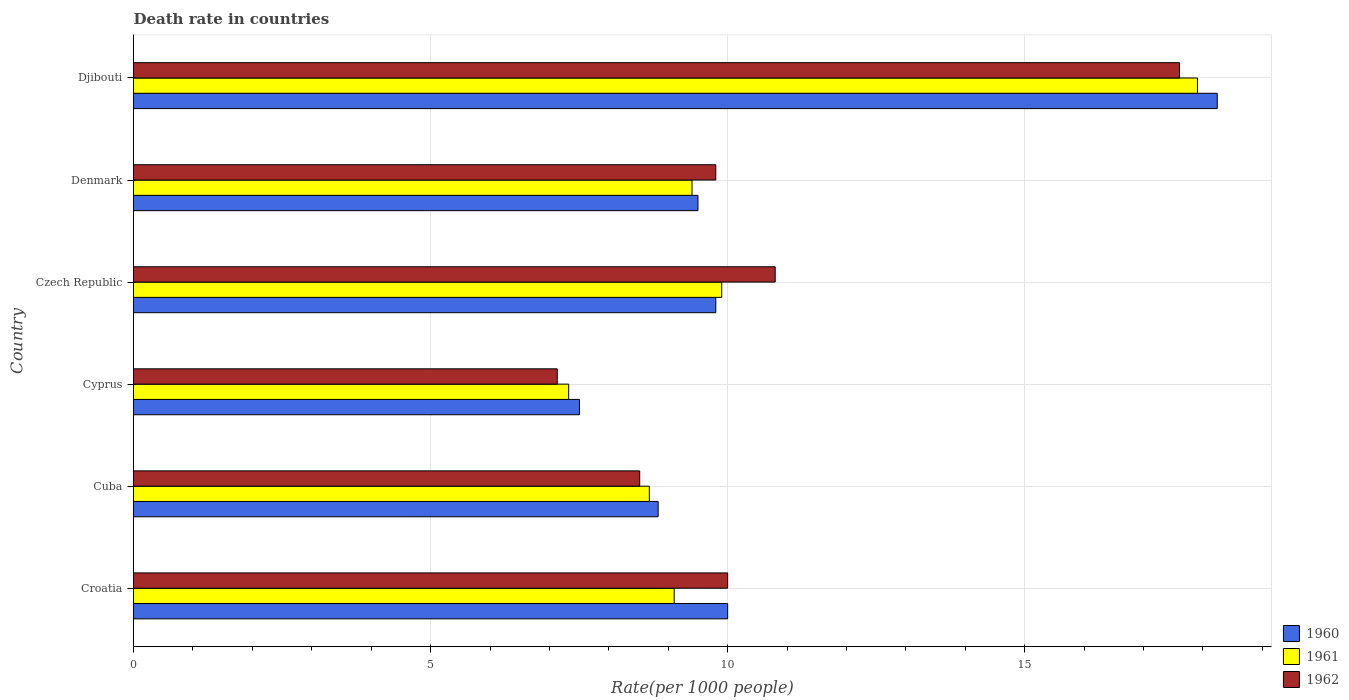How many groups of bars are there?
Your answer should be compact. 6. Are the number of bars per tick equal to the number of legend labels?
Offer a very short reply. Yes. How many bars are there on the 3rd tick from the top?
Provide a short and direct response. 3. What is the label of the 5th group of bars from the top?
Provide a short and direct response. Cuba. In how many cases, is the number of bars for a given country not equal to the number of legend labels?
Your answer should be very brief. 0. What is the death rate in 1962 in Croatia?
Ensure brevity in your answer.  10. Across all countries, what is the maximum death rate in 1962?
Make the answer very short. 17.6. Across all countries, what is the minimum death rate in 1960?
Your answer should be compact. 7.51. In which country was the death rate in 1962 maximum?
Keep it short and to the point. Djibouti. In which country was the death rate in 1962 minimum?
Offer a terse response. Cyprus. What is the total death rate in 1961 in the graph?
Your answer should be compact. 62.31. What is the difference between the death rate in 1960 in Cuba and that in Czech Republic?
Ensure brevity in your answer.  -0.97. What is the difference between the death rate in 1961 in Cuba and the death rate in 1962 in Djibouti?
Your answer should be compact. -8.92. What is the average death rate in 1962 per country?
Offer a terse response. 10.64. What is the difference between the death rate in 1960 and death rate in 1961 in Cuba?
Provide a succinct answer. 0.15. What is the ratio of the death rate in 1961 in Cuba to that in Djibouti?
Make the answer very short. 0.48. What is the difference between the highest and the second highest death rate in 1962?
Provide a short and direct response. 6.8. What is the difference between the highest and the lowest death rate in 1962?
Make the answer very short. 10.47. In how many countries, is the death rate in 1962 greater than the average death rate in 1962 taken over all countries?
Your answer should be very brief. 2. Is the sum of the death rate in 1960 in Croatia and Denmark greater than the maximum death rate in 1961 across all countries?
Offer a terse response. Yes. What does the 2nd bar from the bottom in Czech Republic represents?
Your response must be concise. 1961. How many bars are there?
Your response must be concise. 18. Are all the bars in the graph horizontal?
Provide a short and direct response. Yes. How many countries are there in the graph?
Offer a very short reply. 6. Are the values on the major ticks of X-axis written in scientific E-notation?
Offer a very short reply. No. Does the graph contain grids?
Make the answer very short. Yes. What is the title of the graph?
Your answer should be compact. Death rate in countries. Does "1966" appear as one of the legend labels in the graph?
Your answer should be very brief. No. What is the label or title of the X-axis?
Offer a terse response. Rate(per 1000 people). What is the label or title of the Y-axis?
Give a very brief answer. Country. What is the Rate(per 1000 people) of 1961 in Croatia?
Keep it short and to the point. 9.1. What is the Rate(per 1000 people) in 1960 in Cuba?
Offer a very short reply. 8.83. What is the Rate(per 1000 people) of 1961 in Cuba?
Provide a short and direct response. 8.68. What is the Rate(per 1000 people) of 1962 in Cuba?
Give a very brief answer. 8.52. What is the Rate(per 1000 people) in 1960 in Cyprus?
Your response must be concise. 7.51. What is the Rate(per 1000 people) in 1961 in Cyprus?
Offer a very short reply. 7.32. What is the Rate(per 1000 people) in 1962 in Cyprus?
Make the answer very short. 7.13. What is the Rate(per 1000 people) in 1960 in Czech Republic?
Make the answer very short. 9.8. What is the Rate(per 1000 people) of 1962 in Czech Republic?
Your answer should be very brief. 10.8. What is the Rate(per 1000 people) of 1962 in Denmark?
Give a very brief answer. 9.8. What is the Rate(per 1000 people) of 1960 in Djibouti?
Provide a short and direct response. 18.24. What is the Rate(per 1000 people) of 1961 in Djibouti?
Your answer should be compact. 17.91. What is the Rate(per 1000 people) of 1962 in Djibouti?
Ensure brevity in your answer.  17.6. Across all countries, what is the maximum Rate(per 1000 people) in 1960?
Provide a short and direct response. 18.24. Across all countries, what is the maximum Rate(per 1000 people) in 1961?
Your answer should be compact. 17.91. Across all countries, what is the maximum Rate(per 1000 people) of 1962?
Your answer should be compact. 17.6. Across all countries, what is the minimum Rate(per 1000 people) in 1960?
Provide a short and direct response. 7.51. Across all countries, what is the minimum Rate(per 1000 people) in 1961?
Keep it short and to the point. 7.32. Across all countries, what is the minimum Rate(per 1000 people) of 1962?
Keep it short and to the point. 7.13. What is the total Rate(per 1000 people) in 1960 in the graph?
Your response must be concise. 63.88. What is the total Rate(per 1000 people) in 1961 in the graph?
Your answer should be compact. 62.31. What is the total Rate(per 1000 people) of 1962 in the graph?
Keep it short and to the point. 63.86. What is the difference between the Rate(per 1000 people) in 1960 in Croatia and that in Cuba?
Give a very brief answer. 1.17. What is the difference between the Rate(per 1000 people) of 1961 in Croatia and that in Cuba?
Provide a succinct answer. 0.42. What is the difference between the Rate(per 1000 people) of 1962 in Croatia and that in Cuba?
Provide a succinct answer. 1.48. What is the difference between the Rate(per 1000 people) in 1960 in Croatia and that in Cyprus?
Your answer should be very brief. 2.49. What is the difference between the Rate(per 1000 people) in 1961 in Croatia and that in Cyprus?
Offer a very short reply. 1.78. What is the difference between the Rate(per 1000 people) of 1962 in Croatia and that in Cyprus?
Your response must be concise. 2.87. What is the difference between the Rate(per 1000 people) of 1962 in Croatia and that in Czech Republic?
Offer a terse response. -0.8. What is the difference between the Rate(per 1000 people) in 1960 in Croatia and that in Denmark?
Make the answer very short. 0.5. What is the difference between the Rate(per 1000 people) in 1961 in Croatia and that in Denmark?
Provide a succinct answer. -0.3. What is the difference between the Rate(per 1000 people) in 1962 in Croatia and that in Denmark?
Your response must be concise. 0.2. What is the difference between the Rate(per 1000 people) of 1960 in Croatia and that in Djibouti?
Offer a terse response. -8.24. What is the difference between the Rate(per 1000 people) of 1961 in Croatia and that in Djibouti?
Ensure brevity in your answer.  -8.81. What is the difference between the Rate(per 1000 people) of 1962 in Croatia and that in Djibouti?
Offer a very short reply. -7.6. What is the difference between the Rate(per 1000 people) of 1960 in Cuba and that in Cyprus?
Ensure brevity in your answer.  1.32. What is the difference between the Rate(per 1000 people) in 1961 in Cuba and that in Cyprus?
Keep it short and to the point. 1.36. What is the difference between the Rate(per 1000 people) in 1962 in Cuba and that in Cyprus?
Keep it short and to the point. 1.39. What is the difference between the Rate(per 1000 people) of 1960 in Cuba and that in Czech Republic?
Ensure brevity in your answer.  -0.97. What is the difference between the Rate(per 1000 people) in 1961 in Cuba and that in Czech Republic?
Give a very brief answer. -1.22. What is the difference between the Rate(per 1000 people) in 1962 in Cuba and that in Czech Republic?
Keep it short and to the point. -2.28. What is the difference between the Rate(per 1000 people) of 1960 in Cuba and that in Denmark?
Make the answer very short. -0.67. What is the difference between the Rate(per 1000 people) in 1961 in Cuba and that in Denmark?
Keep it short and to the point. -0.72. What is the difference between the Rate(per 1000 people) of 1962 in Cuba and that in Denmark?
Provide a succinct answer. -1.28. What is the difference between the Rate(per 1000 people) in 1960 in Cuba and that in Djibouti?
Offer a very short reply. -9.41. What is the difference between the Rate(per 1000 people) in 1961 in Cuba and that in Djibouti?
Your response must be concise. -9.22. What is the difference between the Rate(per 1000 people) in 1962 in Cuba and that in Djibouti?
Make the answer very short. -9.08. What is the difference between the Rate(per 1000 people) of 1960 in Cyprus and that in Czech Republic?
Your response must be concise. -2.29. What is the difference between the Rate(per 1000 people) in 1961 in Cyprus and that in Czech Republic?
Offer a terse response. -2.58. What is the difference between the Rate(per 1000 people) in 1962 in Cyprus and that in Czech Republic?
Provide a short and direct response. -3.67. What is the difference between the Rate(per 1000 people) in 1960 in Cyprus and that in Denmark?
Provide a short and direct response. -1.99. What is the difference between the Rate(per 1000 people) in 1961 in Cyprus and that in Denmark?
Offer a very short reply. -2.08. What is the difference between the Rate(per 1000 people) in 1962 in Cyprus and that in Denmark?
Offer a terse response. -2.67. What is the difference between the Rate(per 1000 people) in 1960 in Cyprus and that in Djibouti?
Your response must be concise. -10.73. What is the difference between the Rate(per 1000 people) in 1961 in Cyprus and that in Djibouti?
Offer a terse response. -10.58. What is the difference between the Rate(per 1000 people) of 1962 in Cyprus and that in Djibouti?
Provide a short and direct response. -10.47. What is the difference between the Rate(per 1000 people) in 1961 in Czech Republic and that in Denmark?
Your answer should be compact. 0.5. What is the difference between the Rate(per 1000 people) in 1962 in Czech Republic and that in Denmark?
Offer a very short reply. 1. What is the difference between the Rate(per 1000 people) of 1960 in Czech Republic and that in Djibouti?
Offer a very short reply. -8.44. What is the difference between the Rate(per 1000 people) in 1961 in Czech Republic and that in Djibouti?
Offer a very short reply. -8.01. What is the difference between the Rate(per 1000 people) of 1962 in Czech Republic and that in Djibouti?
Provide a succinct answer. -6.8. What is the difference between the Rate(per 1000 people) in 1960 in Denmark and that in Djibouti?
Your answer should be very brief. -8.74. What is the difference between the Rate(per 1000 people) in 1961 in Denmark and that in Djibouti?
Offer a terse response. -8.51. What is the difference between the Rate(per 1000 people) of 1962 in Denmark and that in Djibouti?
Your answer should be compact. -7.8. What is the difference between the Rate(per 1000 people) of 1960 in Croatia and the Rate(per 1000 people) of 1961 in Cuba?
Give a very brief answer. 1.32. What is the difference between the Rate(per 1000 people) in 1960 in Croatia and the Rate(per 1000 people) in 1962 in Cuba?
Give a very brief answer. 1.48. What is the difference between the Rate(per 1000 people) in 1961 in Croatia and the Rate(per 1000 people) in 1962 in Cuba?
Offer a very short reply. 0.58. What is the difference between the Rate(per 1000 people) in 1960 in Croatia and the Rate(per 1000 people) in 1961 in Cyprus?
Provide a succinct answer. 2.68. What is the difference between the Rate(per 1000 people) in 1960 in Croatia and the Rate(per 1000 people) in 1962 in Cyprus?
Offer a terse response. 2.87. What is the difference between the Rate(per 1000 people) in 1961 in Croatia and the Rate(per 1000 people) in 1962 in Cyprus?
Ensure brevity in your answer.  1.97. What is the difference between the Rate(per 1000 people) in 1960 in Croatia and the Rate(per 1000 people) in 1961 in Czech Republic?
Offer a very short reply. 0.1. What is the difference between the Rate(per 1000 people) in 1960 in Croatia and the Rate(per 1000 people) in 1962 in Denmark?
Make the answer very short. 0.2. What is the difference between the Rate(per 1000 people) in 1961 in Croatia and the Rate(per 1000 people) in 1962 in Denmark?
Provide a succinct answer. -0.7. What is the difference between the Rate(per 1000 people) of 1960 in Croatia and the Rate(per 1000 people) of 1961 in Djibouti?
Give a very brief answer. -7.91. What is the difference between the Rate(per 1000 people) in 1960 in Croatia and the Rate(per 1000 people) in 1962 in Djibouti?
Your response must be concise. -7.6. What is the difference between the Rate(per 1000 people) in 1961 in Croatia and the Rate(per 1000 people) in 1962 in Djibouti?
Offer a terse response. -8.5. What is the difference between the Rate(per 1000 people) of 1960 in Cuba and the Rate(per 1000 people) of 1961 in Cyprus?
Provide a succinct answer. 1.51. What is the difference between the Rate(per 1000 people) of 1960 in Cuba and the Rate(per 1000 people) of 1962 in Cyprus?
Give a very brief answer. 1.7. What is the difference between the Rate(per 1000 people) in 1961 in Cuba and the Rate(per 1000 people) in 1962 in Cyprus?
Give a very brief answer. 1.55. What is the difference between the Rate(per 1000 people) in 1960 in Cuba and the Rate(per 1000 people) in 1961 in Czech Republic?
Your response must be concise. -1.07. What is the difference between the Rate(per 1000 people) in 1960 in Cuba and the Rate(per 1000 people) in 1962 in Czech Republic?
Keep it short and to the point. -1.97. What is the difference between the Rate(per 1000 people) in 1961 in Cuba and the Rate(per 1000 people) in 1962 in Czech Republic?
Provide a short and direct response. -2.12. What is the difference between the Rate(per 1000 people) in 1960 in Cuba and the Rate(per 1000 people) in 1961 in Denmark?
Give a very brief answer. -0.57. What is the difference between the Rate(per 1000 people) of 1960 in Cuba and the Rate(per 1000 people) of 1962 in Denmark?
Give a very brief answer. -0.97. What is the difference between the Rate(per 1000 people) of 1961 in Cuba and the Rate(per 1000 people) of 1962 in Denmark?
Give a very brief answer. -1.12. What is the difference between the Rate(per 1000 people) of 1960 in Cuba and the Rate(per 1000 people) of 1961 in Djibouti?
Ensure brevity in your answer.  -9.08. What is the difference between the Rate(per 1000 people) in 1960 in Cuba and the Rate(per 1000 people) in 1962 in Djibouti?
Your response must be concise. -8.77. What is the difference between the Rate(per 1000 people) in 1961 in Cuba and the Rate(per 1000 people) in 1962 in Djibouti?
Keep it short and to the point. -8.92. What is the difference between the Rate(per 1000 people) in 1960 in Cyprus and the Rate(per 1000 people) in 1961 in Czech Republic?
Ensure brevity in your answer.  -2.39. What is the difference between the Rate(per 1000 people) in 1960 in Cyprus and the Rate(per 1000 people) in 1962 in Czech Republic?
Offer a very short reply. -3.29. What is the difference between the Rate(per 1000 people) in 1961 in Cyprus and the Rate(per 1000 people) in 1962 in Czech Republic?
Give a very brief answer. -3.48. What is the difference between the Rate(per 1000 people) in 1960 in Cyprus and the Rate(per 1000 people) in 1961 in Denmark?
Provide a succinct answer. -1.89. What is the difference between the Rate(per 1000 people) in 1960 in Cyprus and the Rate(per 1000 people) in 1962 in Denmark?
Your answer should be very brief. -2.29. What is the difference between the Rate(per 1000 people) in 1961 in Cyprus and the Rate(per 1000 people) in 1962 in Denmark?
Offer a terse response. -2.48. What is the difference between the Rate(per 1000 people) of 1960 in Cyprus and the Rate(per 1000 people) of 1961 in Djibouti?
Your answer should be compact. -10.4. What is the difference between the Rate(per 1000 people) of 1960 in Cyprus and the Rate(per 1000 people) of 1962 in Djibouti?
Ensure brevity in your answer.  -10.1. What is the difference between the Rate(per 1000 people) of 1961 in Cyprus and the Rate(per 1000 people) of 1962 in Djibouti?
Keep it short and to the point. -10.28. What is the difference between the Rate(per 1000 people) of 1960 in Czech Republic and the Rate(per 1000 people) of 1961 in Djibouti?
Offer a terse response. -8.11. What is the difference between the Rate(per 1000 people) in 1960 in Czech Republic and the Rate(per 1000 people) in 1962 in Djibouti?
Offer a very short reply. -7.8. What is the difference between the Rate(per 1000 people) in 1961 in Czech Republic and the Rate(per 1000 people) in 1962 in Djibouti?
Make the answer very short. -7.7. What is the difference between the Rate(per 1000 people) in 1960 in Denmark and the Rate(per 1000 people) in 1961 in Djibouti?
Your response must be concise. -8.41. What is the difference between the Rate(per 1000 people) of 1960 in Denmark and the Rate(per 1000 people) of 1962 in Djibouti?
Provide a succinct answer. -8.1. What is the difference between the Rate(per 1000 people) of 1961 in Denmark and the Rate(per 1000 people) of 1962 in Djibouti?
Make the answer very short. -8.2. What is the average Rate(per 1000 people) in 1960 per country?
Your response must be concise. 10.65. What is the average Rate(per 1000 people) in 1961 per country?
Your response must be concise. 10.39. What is the average Rate(per 1000 people) of 1962 per country?
Keep it short and to the point. 10.64. What is the difference between the Rate(per 1000 people) of 1960 and Rate(per 1000 people) of 1961 in Cuba?
Offer a very short reply. 0.15. What is the difference between the Rate(per 1000 people) in 1960 and Rate(per 1000 people) in 1962 in Cuba?
Give a very brief answer. 0.31. What is the difference between the Rate(per 1000 people) in 1961 and Rate(per 1000 people) in 1962 in Cuba?
Give a very brief answer. 0.16. What is the difference between the Rate(per 1000 people) of 1960 and Rate(per 1000 people) of 1961 in Cyprus?
Keep it short and to the point. 0.18. What is the difference between the Rate(per 1000 people) in 1960 and Rate(per 1000 people) in 1962 in Cyprus?
Provide a short and direct response. 0.37. What is the difference between the Rate(per 1000 people) of 1961 and Rate(per 1000 people) of 1962 in Cyprus?
Make the answer very short. 0.19. What is the difference between the Rate(per 1000 people) of 1960 and Rate(per 1000 people) of 1961 in Czech Republic?
Your answer should be very brief. -0.1. What is the difference between the Rate(per 1000 people) in 1961 and Rate(per 1000 people) in 1962 in Czech Republic?
Provide a succinct answer. -0.9. What is the difference between the Rate(per 1000 people) in 1960 and Rate(per 1000 people) in 1962 in Denmark?
Offer a terse response. -0.3. What is the difference between the Rate(per 1000 people) of 1960 and Rate(per 1000 people) of 1961 in Djibouti?
Offer a terse response. 0.33. What is the difference between the Rate(per 1000 people) of 1960 and Rate(per 1000 people) of 1962 in Djibouti?
Provide a succinct answer. 0.64. What is the difference between the Rate(per 1000 people) in 1961 and Rate(per 1000 people) in 1962 in Djibouti?
Provide a succinct answer. 0.3. What is the ratio of the Rate(per 1000 people) in 1960 in Croatia to that in Cuba?
Give a very brief answer. 1.13. What is the ratio of the Rate(per 1000 people) of 1961 in Croatia to that in Cuba?
Keep it short and to the point. 1.05. What is the ratio of the Rate(per 1000 people) of 1962 in Croatia to that in Cuba?
Make the answer very short. 1.17. What is the ratio of the Rate(per 1000 people) of 1960 in Croatia to that in Cyprus?
Provide a succinct answer. 1.33. What is the ratio of the Rate(per 1000 people) in 1961 in Croatia to that in Cyprus?
Offer a terse response. 1.24. What is the ratio of the Rate(per 1000 people) in 1962 in Croatia to that in Cyprus?
Make the answer very short. 1.4. What is the ratio of the Rate(per 1000 people) in 1960 in Croatia to that in Czech Republic?
Give a very brief answer. 1.02. What is the ratio of the Rate(per 1000 people) in 1961 in Croatia to that in Czech Republic?
Keep it short and to the point. 0.92. What is the ratio of the Rate(per 1000 people) of 1962 in Croatia to that in Czech Republic?
Ensure brevity in your answer.  0.93. What is the ratio of the Rate(per 1000 people) in 1960 in Croatia to that in Denmark?
Give a very brief answer. 1.05. What is the ratio of the Rate(per 1000 people) in 1961 in Croatia to that in Denmark?
Ensure brevity in your answer.  0.97. What is the ratio of the Rate(per 1000 people) of 1962 in Croatia to that in Denmark?
Your answer should be compact. 1.02. What is the ratio of the Rate(per 1000 people) of 1960 in Croatia to that in Djibouti?
Give a very brief answer. 0.55. What is the ratio of the Rate(per 1000 people) of 1961 in Croatia to that in Djibouti?
Offer a very short reply. 0.51. What is the ratio of the Rate(per 1000 people) of 1962 in Croatia to that in Djibouti?
Offer a very short reply. 0.57. What is the ratio of the Rate(per 1000 people) in 1960 in Cuba to that in Cyprus?
Your answer should be compact. 1.18. What is the ratio of the Rate(per 1000 people) in 1961 in Cuba to that in Cyprus?
Make the answer very short. 1.19. What is the ratio of the Rate(per 1000 people) in 1962 in Cuba to that in Cyprus?
Give a very brief answer. 1.19. What is the ratio of the Rate(per 1000 people) in 1960 in Cuba to that in Czech Republic?
Your answer should be compact. 0.9. What is the ratio of the Rate(per 1000 people) of 1961 in Cuba to that in Czech Republic?
Offer a terse response. 0.88. What is the ratio of the Rate(per 1000 people) in 1962 in Cuba to that in Czech Republic?
Provide a short and direct response. 0.79. What is the ratio of the Rate(per 1000 people) in 1960 in Cuba to that in Denmark?
Provide a short and direct response. 0.93. What is the ratio of the Rate(per 1000 people) in 1961 in Cuba to that in Denmark?
Make the answer very short. 0.92. What is the ratio of the Rate(per 1000 people) of 1962 in Cuba to that in Denmark?
Give a very brief answer. 0.87. What is the ratio of the Rate(per 1000 people) of 1960 in Cuba to that in Djibouti?
Your answer should be compact. 0.48. What is the ratio of the Rate(per 1000 people) of 1961 in Cuba to that in Djibouti?
Offer a very short reply. 0.48. What is the ratio of the Rate(per 1000 people) of 1962 in Cuba to that in Djibouti?
Your answer should be compact. 0.48. What is the ratio of the Rate(per 1000 people) of 1960 in Cyprus to that in Czech Republic?
Provide a short and direct response. 0.77. What is the ratio of the Rate(per 1000 people) of 1961 in Cyprus to that in Czech Republic?
Your answer should be very brief. 0.74. What is the ratio of the Rate(per 1000 people) in 1962 in Cyprus to that in Czech Republic?
Your answer should be very brief. 0.66. What is the ratio of the Rate(per 1000 people) of 1960 in Cyprus to that in Denmark?
Make the answer very short. 0.79. What is the ratio of the Rate(per 1000 people) of 1961 in Cyprus to that in Denmark?
Give a very brief answer. 0.78. What is the ratio of the Rate(per 1000 people) of 1962 in Cyprus to that in Denmark?
Make the answer very short. 0.73. What is the ratio of the Rate(per 1000 people) of 1960 in Cyprus to that in Djibouti?
Keep it short and to the point. 0.41. What is the ratio of the Rate(per 1000 people) in 1961 in Cyprus to that in Djibouti?
Make the answer very short. 0.41. What is the ratio of the Rate(per 1000 people) of 1962 in Cyprus to that in Djibouti?
Ensure brevity in your answer.  0.41. What is the ratio of the Rate(per 1000 people) of 1960 in Czech Republic to that in Denmark?
Provide a succinct answer. 1.03. What is the ratio of the Rate(per 1000 people) of 1961 in Czech Republic to that in Denmark?
Your answer should be compact. 1.05. What is the ratio of the Rate(per 1000 people) of 1962 in Czech Republic to that in Denmark?
Provide a succinct answer. 1.1. What is the ratio of the Rate(per 1000 people) in 1960 in Czech Republic to that in Djibouti?
Give a very brief answer. 0.54. What is the ratio of the Rate(per 1000 people) in 1961 in Czech Republic to that in Djibouti?
Ensure brevity in your answer.  0.55. What is the ratio of the Rate(per 1000 people) of 1962 in Czech Republic to that in Djibouti?
Your response must be concise. 0.61. What is the ratio of the Rate(per 1000 people) in 1960 in Denmark to that in Djibouti?
Ensure brevity in your answer.  0.52. What is the ratio of the Rate(per 1000 people) in 1961 in Denmark to that in Djibouti?
Provide a succinct answer. 0.52. What is the ratio of the Rate(per 1000 people) of 1962 in Denmark to that in Djibouti?
Give a very brief answer. 0.56. What is the difference between the highest and the second highest Rate(per 1000 people) of 1960?
Give a very brief answer. 8.24. What is the difference between the highest and the second highest Rate(per 1000 people) of 1961?
Ensure brevity in your answer.  8.01. What is the difference between the highest and the second highest Rate(per 1000 people) of 1962?
Make the answer very short. 6.8. What is the difference between the highest and the lowest Rate(per 1000 people) of 1960?
Provide a succinct answer. 10.73. What is the difference between the highest and the lowest Rate(per 1000 people) in 1961?
Provide a short and direct response. 10.58. What is the difference between the highest and the lowest Rate(per 1000 people) in 1962?
Your answer should be compact. 10.47. 